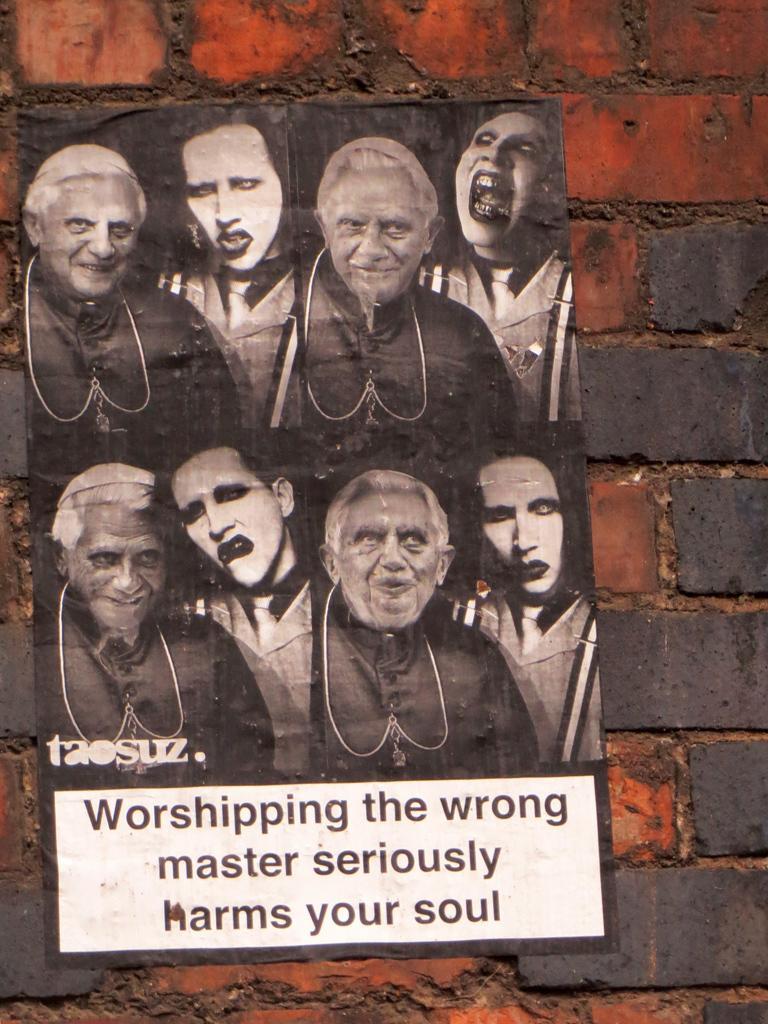In one or two sentences, can you explain what this image depicts? In this picture we can see a poster on the wall. 